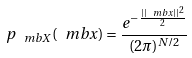<formula> <loc_0><loc_0><loc_500><loc_500>p _ { \ m b X } ( \ m b x ) = \frac { e ^ { - \frac { | | \ m b x | | ^ { 2 } } { 2 } } } { ( 2 \pi ) ^ { N / 2 } }</formula> 